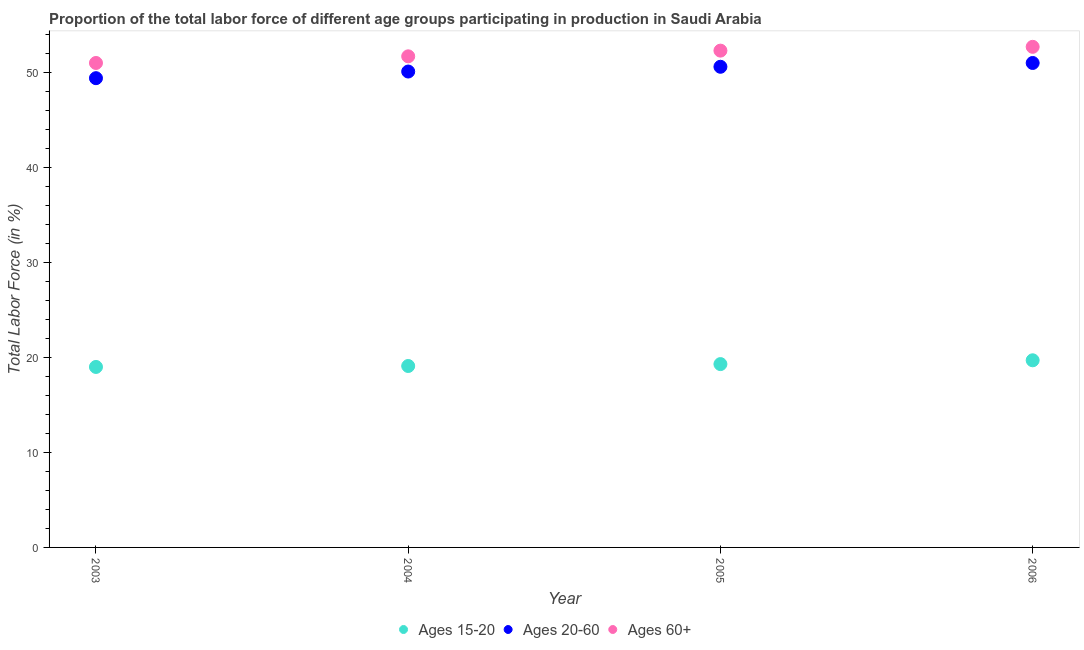How many different coloured dotlines are there?
Offer a very short reply. 3. Is the number of dotlines equal to the number of legend labels?
Offer a terse response. Yes. What is the percentage of labor force within the age group 15-20 in 2003?
Your response must be concise. 19. What is the total percentage of labor force within the age group 15-20 in the graph?
Provide a short and direct response. 77.1. What is the difference between the percentage of labor force within the age group 20-60 in 2004 and that in 2005?
Offer a very short reply. -0.5. What is the difference between the percentage of labor force within the age group 20-60 in 2005 and the percentage of labor force within the age group 15-20 in 2004?
Your response must be concise. 31.5. What is the average percentage of labor force within the age group 15-20 per year?
Your response must be concise. 19.28. In the year 2006, what is the difference between the percentage of labor force within the age group 20-60 and percentage of labor force above age 60?
Your answer should be very brief. -1.7. In how many years, is the percentage of labor force within the age group 20-60 greater than 6 %?
Keep it short and to the point. 4. What is the ratio of the percentage of labor force within the age group 15-20 in 2005 to that in 2006?
Make the answer very short. 0.98. Is the percentage of labor force within the age group 15-20 in 2004 less than that in 2006?
Keep it short and to the point. Yes. What is the difference between the highest and the second highest percentage of labor force within the age group 15-20?
Provide a short and direct response. 0.4. What is the difference between the highest and the lowest percentage of labor force within the age group 15-20?
Ensure brevity in your answer.  0.7. In how many years, is the percentage of labor force within the age group 20-60 greater than the average percentage of labor force within the age group 20-60 taken over all years?
Ensure brevity in your answer.  2. Is the sum of the percentage of labor force above age 60 in 2003 and 2005 greater than the maximum percentage of labor force within the age group 20-60 across all years?
Give a very brief answer. Yes. Is the percentage of labor force above age 60 strictly greater than the percentage of labor force within the age group 20-60 over the years?
Keep it short and to the point. Yes. Is the percentage of labor force within the age group 20-60 strictly less than the percentage of labor force above age 60 over the years?
Make the answer very short. Yes. How many dotlines are there?
Your response must be concise. 3. How many years are there in the graph?
Your response must be concise. 4. What is the difference between two consecutive major ticks on the Y-axis?
Your response must be concise. 10. Are the values on the major ticks of Y-axis written in scientific E-notation?
Offer a terse response. No. Does the graph contain grids?
Give a very brief answer. No. Where does the legend appear in the graph?
Give a very brief answer. Bottom center. How are the legend labels stacked?
Your response must be concise. Horizontal. What is the title of the graph?
Your response must be concise. Proportion of the total labor force of different age groups participating in production in Saudi Arabia. What is the label or title of the Y-axis?
Ensure brevity in your answer.  Total Labor Force (in %). What is the Total Labor Force (in %) in Ages 15-20 in 2003?
Provide a succinct answer. 19. What is the Total Labor Force (in %) of Ages 20-60 in 2003?
Provide a short and direct response. 49.4. What is the Total Labor Force (in %) in Ages 15-20 in 2004?
Your response must be concise. 19.1. What is the Total Labor Force (in %) in Ages 20-60 in 2004?
Make the answer very short. 50.1. What is the Total Labor Force (in %) in Ages 60+ in 2004?
Offer a terse response. 51.7. What is the Total Labor Force (in %) in Ages 15-20 in 2005?
Your response must be concise. 19.3. What is the Total Labor Force (in %) in Ages 20-60 in 2005?
Provide a short and direct response. 50.6. What is the Total Labor Force (in %) in Ages 60+ in 2005?
Your response must be concise. 52.3. What is the Total Labor Force (in %) of Ages 15-20 in 2006?
Provide a succinct answer. 19.7. What is the Total Labor Force (in %) of Ages 20-60 in 2006?
Provide a succinct answer. 51. What is the Total Labor Force (in %) of Ages 60+ in 2006?
Make the answer very short. 52.7. Across all years, what is the maximum Total Labor Force (in %) of Ages 15-20?
Offer a very short reply. 19.7. Across all years, what is the maximum Total Labor Force (in %) of Ages 60+?
Provide a short and direct response. 52.7. Across all years, what is the minimum Total Labor Force (in %) of Ages 20-60?
Give a very brief answer. 49.4. What is the total Total Labor Force (in %) of Ages 15-20 in the graph?
Provide a short and direct response. 77.1. What is the total Total Labor Force (in %) of Ages 20-60 in the graph?
Provide a succinct answer. 201.1. What is the total Total Labor Force (in %) of Ages 60+ in the graph?
Provide a short and direct response. 207.7. What is the difference between the Total Labor Force (in %) in Ages 15-20 in 2003 and that in 2004?
Ensure brevity in your answer.  -0.1. What is the difference between the Total Labor Force (in %) of Ages 20-60 in 2003 and that in 2006?
Provide a short and direct response. -1.6. What is the difference between the Total Labor Force (in %) of Ages 15-20 in 2004 and that in 2005?
Give a very brief answer. -0.2. What is the difference between the Total Labor Force (in %) in Ages 60+ in 2004 and that in 2006?
Your answer should be compact. -1. What is the difference between the Total Labor Force (in %) in Ages 15-20 in 2005 and that in 2006?
Provide a short and direct response. -0.4. What is the difference between the Total Labor Force (in %) in Ages 20-60 in 2005 and that in 2006?
Make the answer very short. -0.4. What is the difference between the Total Labor Force (in %) in Ages 15-20 in 2003 and the Total Labor Force (in %) in Ages 20-60 in 2004?
Provide a succinct answer. -31.1. What is the difference between the Total Labor Force (in %) of Ages 15-20 in 2003 and the Total Labor Force (in %) of Ages 60+ in 2004?
Give a very brief answer. -32.7. What is the difference between the Total Labor Force (in %) in Ages 15-20 in 2003 and the Total Labor Force (in %) in Ages 20-60 in 2005?
Keep it short and to the point. -31.6. What is the difference between the Total Labor Force (in %) of Ages 15-20 in 2003 and the Total Labor Force (in %) of Ages 60+ in 2005?
Offer a very short reply. -33.3. What is the difference between the Total Labor Force (in %) in Ages 15-20 in 2003 and the Total Labor Force (in %) in Ages 20-60 in 2006?
Provide a short and direct response. -32. What is the difference between the Total Labor Force (in %) in Ages 15-20 in 2003 and the Total Labor Force (in %) in Ages 60+ in 2006?
Offer a very short reply. -33.7. What is the difference between the Total Labor Force (in %) of Ages 15-20 in 2004 and the Total Labor Force (in %) of Ages 20-60 in 2005?
Offer a terse response. -31.5. What is the difference between the Total Labor Force (in %) in Ages 15-20 in 2004 and the Total Labor Force (in %) in Ages 60+ in 2005?
Keep it short and to the point. -33.2. What is the difference between the Total Labor Force (in %) of Ages 20-60 in 2004 and the Total Labor Force (in %) of Ages 60+ in 2005?
Offer a very short reply. -2.2. What is the difference between the Total Labor Force (in %) of Ages 15-20 in 2004 and the Total Labor Force (in %) of Ages 20-60 in 2006?
Offer a very short reply. -31.9. What is the difference between the Total Labor Force (in %) of Ages 15-20 in 2004 and the Total Labor Force (in %) of Ages 60+ in 2006?
Ensure brevity in your answer.  -33.6. What is the difference between the Total Labor Force (in %) in Ages 20-60 in 2004 and the Total Labor Force (in %) in Ages 60+ in 2006?
Keep it short and to the point. -2.6. What is the difference between the Total Labor Force (in %) of Ages 15-20 in 2005 and the Total Labor Force (in %) of Ages 20-60 in 2006?
Provide a succinct answer. -31.7. What is the difference between the Total Labor Force (in %) in Ages 15-20 in 2005 and the Total Labor Force (in %) in Ages 60+ in 2006?
Offer a terse response. -33.4. What is the difference between the Total Labor Force (in %) in Ages 20-60 in 2005 and the Total Labor Force (in %) in Ages 60+ in 2006?
Your answer should be very brief. -2.1. What is the average Total Labor Force (in %) of Ages 15-20 per year?
Your answer should be very brief. 19.27. What is the average Total Labor Force (in %) of Ages 20-60 per year?
Offer a terse response. 50.27. What is the average Total Labor Force (in %) in Ages 60+ per year?
Your response must be concise. 51.92. In the year 2003, what is the difference between the Total Labor Force (in %) of Ages 15-20 and Total Labor Force (in %) of Ages 20-60?
Offer a terse response. -30.4. In the year 2003, what is the difference between the Total Labor Force (in %) of Ages 15-20 and Total Labor Force (in %) of Ages 60+?
Your answer should be compact. -32. In the year 2004, what is the difference between the Total Labor Force (in %) in Ages 15-20 and Total Labor Force (in %) in Ages 20-60?
Offer a terse response. -31. In the year 2004, what is the difference between the Total Labor Force (in %) in Ages 15-20 and Total Labor Force (in %) in Ages 60+?
Provide a succinct answer. -32.6. In the year 2004, what is the difference between the Total Labor Force (in %) of Ages 20-60 and Total Labor Force (in %) of Ages 60+?
Offer a terse response. -1.6. In the year 2005, what is the difference between the Total Labor Force (in %) in Ages 15-20 and Total Labor Force (in %) in Ages 20-60?
Your response must be concise. -31.3. In the year 2005, what is the difference between the Total Labor Force (in %) of Ages 15-20 and Total Labor Force (in %) of Ages 60+?
Your answer should be compact. -33. In the year 2005, what is the difference between the Total Labor Force (in %) of Ages 20-60 and Total Labor Force (in %) of Ages 60+?
Provide a succinct answer. -1.7. In the year 2006, what is the difference between the Total Labor Force (in %) in Ages 15-20 and Total Labor Force (in %) in Ages 20-60?
Ensure brevity in your answer.  -31.3. In the year 2006, what is the difference between the Total Labor Force (in %) of Ages 15-20 and Total Labor Force (in %) of Ages 60+?
Give a very brief answer. -33. What is the ratio of the Total Labor Force (in %) in Ages 20-60 in 2003 to that in 2004?
Your response must be concise. 0.99. What is the ratio of the Total Labor Force (in %) of Ages 60+ in 2003 to that in 2004?
Make the answer very short. 0.99. What is the ratio of the Total Labor Force (in %) in Ages 15-20 in 2003 to that in 2005?
Your response must be concise. 0.98. What is the ratio of the Total Labor Force (in %) of Ages 20-60 in 2003 to that in 2005?
Your answer should be very brief. 0.98. What is the ratio of the Total Labor Force (in %) in Ages 60+ in 2003 to that in 2005?
Your response must be concise. 0.98. What is the ratio of the Total Labor Force (in %) of Ages 15-20 in 2003 to that in 2006?
Provide a succinct answer. 0.96. What is the ratio of the Total Labor Force (in %) in Ages 20-60 in 2003 to that in 2006?
Your response must be concise. 0.97. What is the ratio of the Total Labor Force (in %) in Ages 60+ in 2003 to that in 2006?
Offer a very short reply. 0.97. What is the ratio of the Total Labor Force (in %) in Ages 20-60 in 2004 to that in 2005?
Your answer should be compact. 0.99. What is the ratio of the Total Labor Force (in %) in Ages 15-20 in 2004 to that in 2006?
Make the answer very short. 0.97. What is the ratio of the Total Labor Force (in %) of Ages 20-60 in 2004 to that in 2006?
Give a very brief answer. 0.98. What is the ratio of the Total Labor Force (in %) of Ages 15-20 in 2005 to that in 2006?
Make the answer very short. 0.98. What is the ratio of the Total Labor Force (in %) in Ages 20-60 in 2005 to that in 2006?
Make the answer very short. 0.99. What is the ratio of the Total Labor Force (in %) in Ages 60+ in 2005 to that in 2006?
Keep it short and to the point. 0.99. What is the difference between the highest and the second highest Total Labor Force (in %) in Ages 20-60?
Offer a terse response. 0.4. What is the difference between the highest and the second highest Total Labor Force (in %) of Ages 60+?
Keep it short and to the point. 0.4. What is the difference between the highest and the lowest Total Labor Force (in %) in Ages 15-20?
Your answer should be very brief. 0.7. What is the difference between the highest and the lowest Total Labor Force (in %) in Ages 60+?
Offer a very short reply. 1.7. 